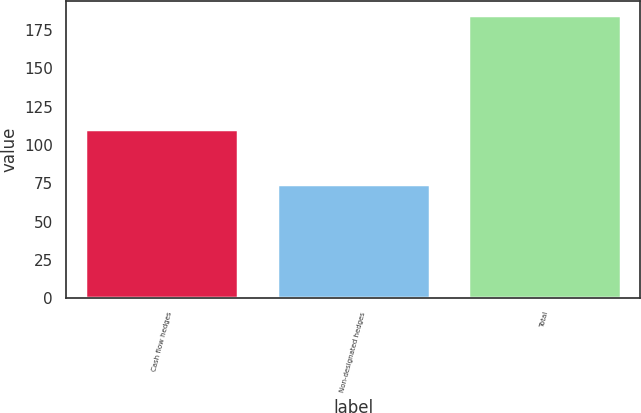<chart> <loc_0><loc_0><loc_500><loc_500><bar_chart><fcel>Cash flow hedges<fcel>Non-designated hedges<fcel>Total<nl><fcel>110.4<fcel>74.4<fcel>184.8<nl></chart> 